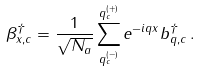<formula> <loc_0><loc_0><loc_500><loc_500>\beta ^ { \dag } _ { x , c } = \frac { 1 } { \sqrt { N _ { a } } } \sum _ { q _ { c } ^ { ( - ) } } ^ { q _ { c } ^ { ( + ) } } e ^ { - i q x } b ^ { \dag } _ { q , c } \, .</formula> 